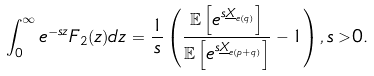<formula> <loc_0><loc_0><loc_500><loc_500>& \int _ { 0 } ^ { \infty } e ^ { - s z } F _ { 2 } ( z ) d z = \frac { 1 } { s } \left ( \frac { \mathbb { E } \left [ e ^ { s \underline { X } _ { e ( q ) } } \right ] } { \mathbb { E } \left [ e ^ { s \underline { X } _ { e ( p + q ) } } \right ] } - 1 \right ) , s > 0 .</formula> 